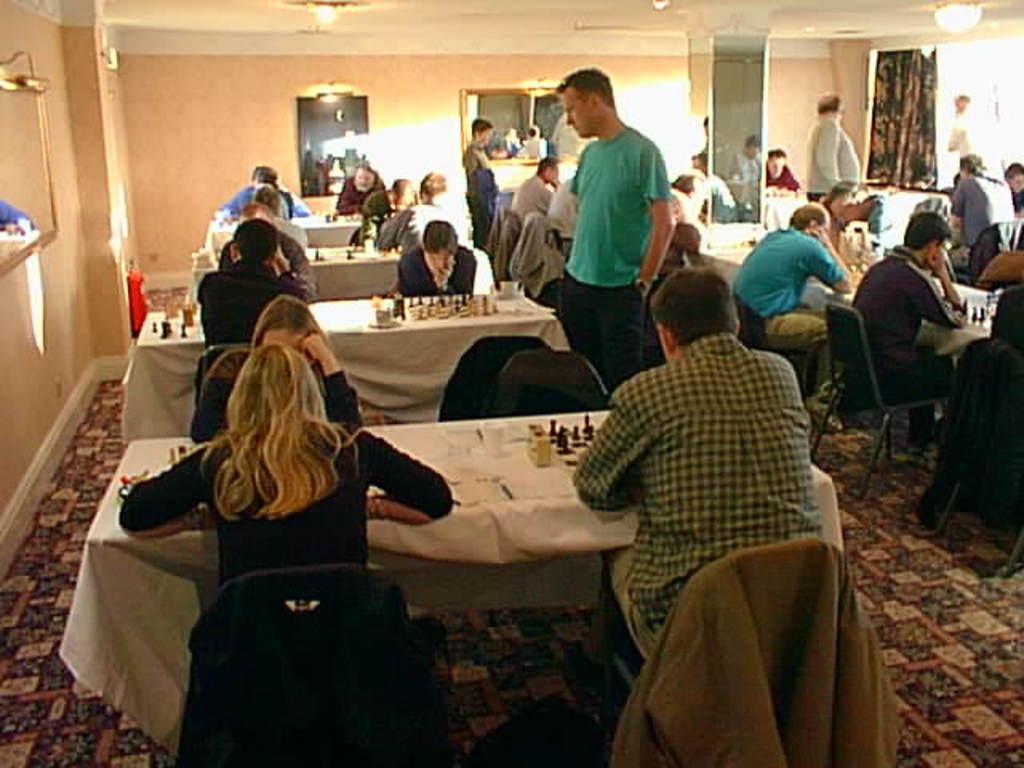Could you give a brief overview of what you see in this image? In this picture we can find some people are sitting on the chairs near to the table and the table is covered with tablecloth. And the people who are sitting are playing a chess. In the background we can find a wall, window, curtain and lights. And some people are standing. 